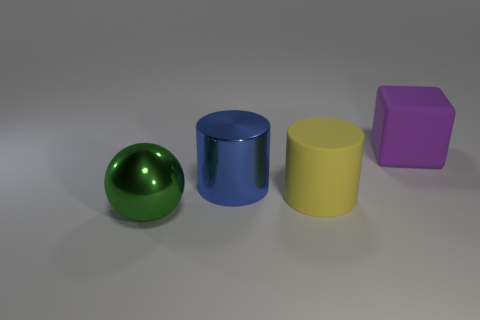What materials do the objects appear to be made of? The green and blue objects look like they have a shiny, metallic finish, while the yellow and purple objects have a matte, rubber-like texture. 